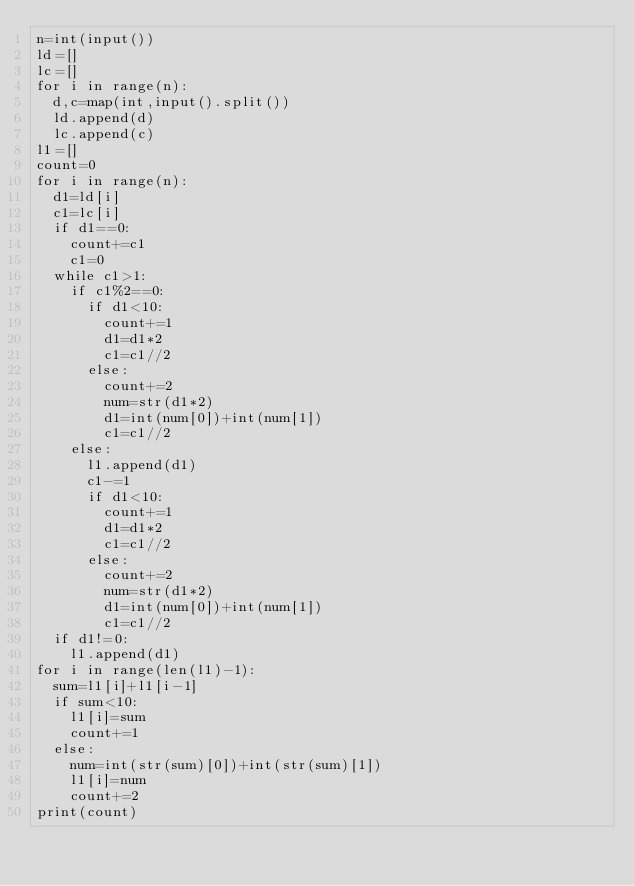<code> <loc_0><loc_0><loc_500><loc_500><_Python_>n=int(input())
ld=[]
lc=[]
for i in range(n):
  d,c=map(int,input().split())
  ld.append(d)
  lc.append(c)
l1=[]
count=0
for i in range(n):
  d1=ld[i]
  c1=lc[i]
  if d1==0:
    count+=c1
    c1=0
  while c1>1:
    if c1%2==0:
      if d1<10:
        count+=1
        d1=d1*2
        c1=c1//2
      else:
        count+=2
        num=str(d1*2)
        d1=int(num[0])+int(num[1])
        c1=c1//2
    else:
      l1.append(d1)
      c1-=1
      if d1<10:
        count+=1
        d1=d1*2
        c1=c1//2
      else:
        count+=2
        num=str(d1*2)
        d1=int(num[0])+int(num[1])
        c1=c1//2
  if d1!=0:
    l1.append(d1)
for i in range(len(l1)-1):
  sum=l1[i]+l1[i-1]
  if sum<10:
    l1[i]=sum
    count+=1
  else:
    num=int(str(sum)[0])+int(str(sum)[1])
    l1[i]=num
    count+=2
print(count)</code> 